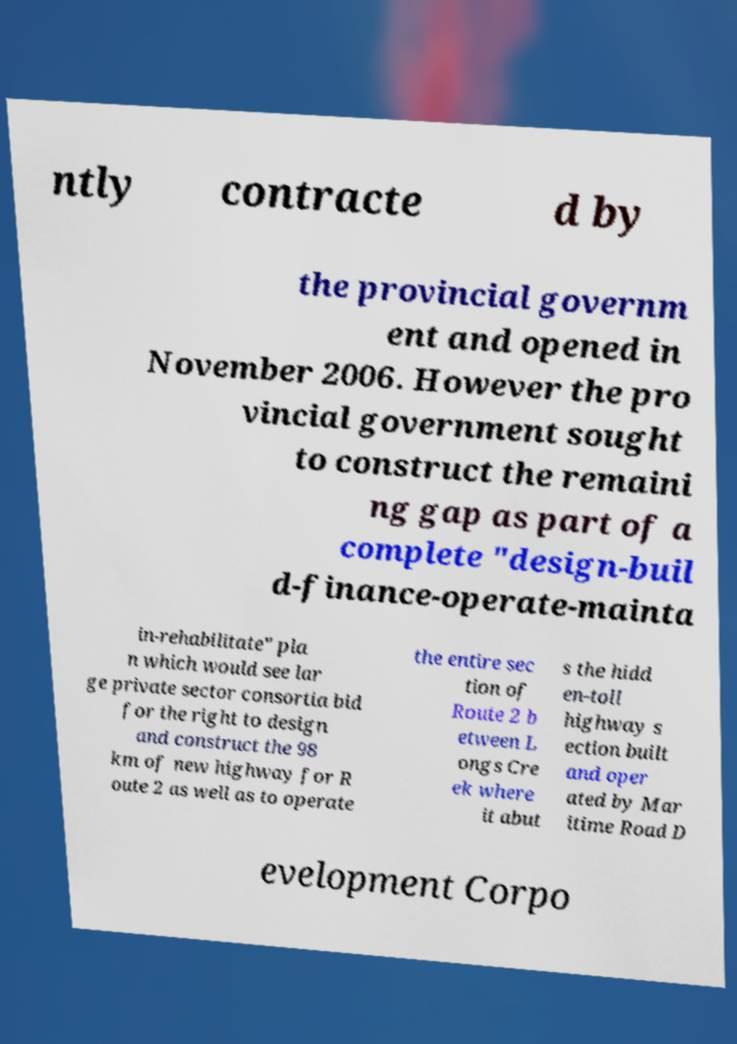Please read and relay the text visible in this image. What does it say? ntly contracte d by the provincial governm ent and opened in November 2006. However the pro vincial government sought to construct the remaini ng gap as part of a complete "design-buil d-finance-operate-mainta in-rehabilitate" pla n which would see lar ge private sector consortia bid for the right to design and construct the 98 km of new highway for R oute 2 as well as to operate the entire sec tion of Route 2 b etween L ongs Cre ek where it abut s the hidd en-toll highway s ection built and oper ated by Mar itime Road D evelopment Corpo 